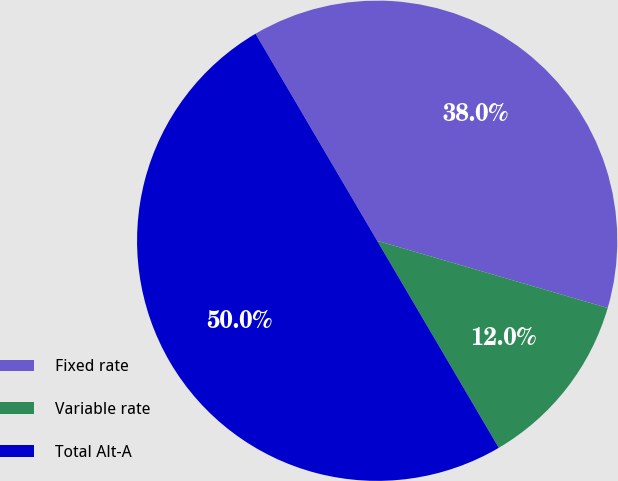<chart> <loc_0><loc_0><loc_500><loc_500><pie_chart><fcel>Fixed rate<fcel>Variable rate<fcel>Total Alt-A<nl><fcel>37.97%<fcel>12.03%<fcel>50.0%<nl></chart> 